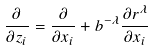<formula> <loc_0><loc_0><loc_500><loc_500>\frac { \partial } { \partial z _ { i } } = \frac { \partial } { \partial x _ { i } } + b ^ { - \lambda } \frac { \partial r ^ { \lambda } } { \partial x _ { i } }</formula> 